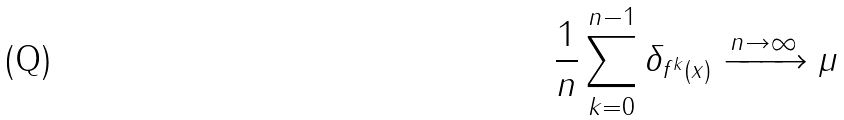Convert formula to latex. <formula><loc_0><loc_0><loc_500><loc_500>\frac { 1 } { n } \sum _ { k = 0 } ^ { n - 1 } \delta _ { f ^ { k } ( x ) } \xrightarrow { n \to \infty } \mu</formula> 